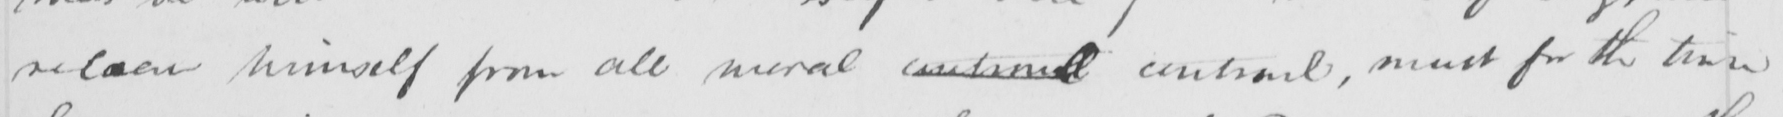What is written in this line of handwriting? release himself from all moral  controull  controul , must for the time 